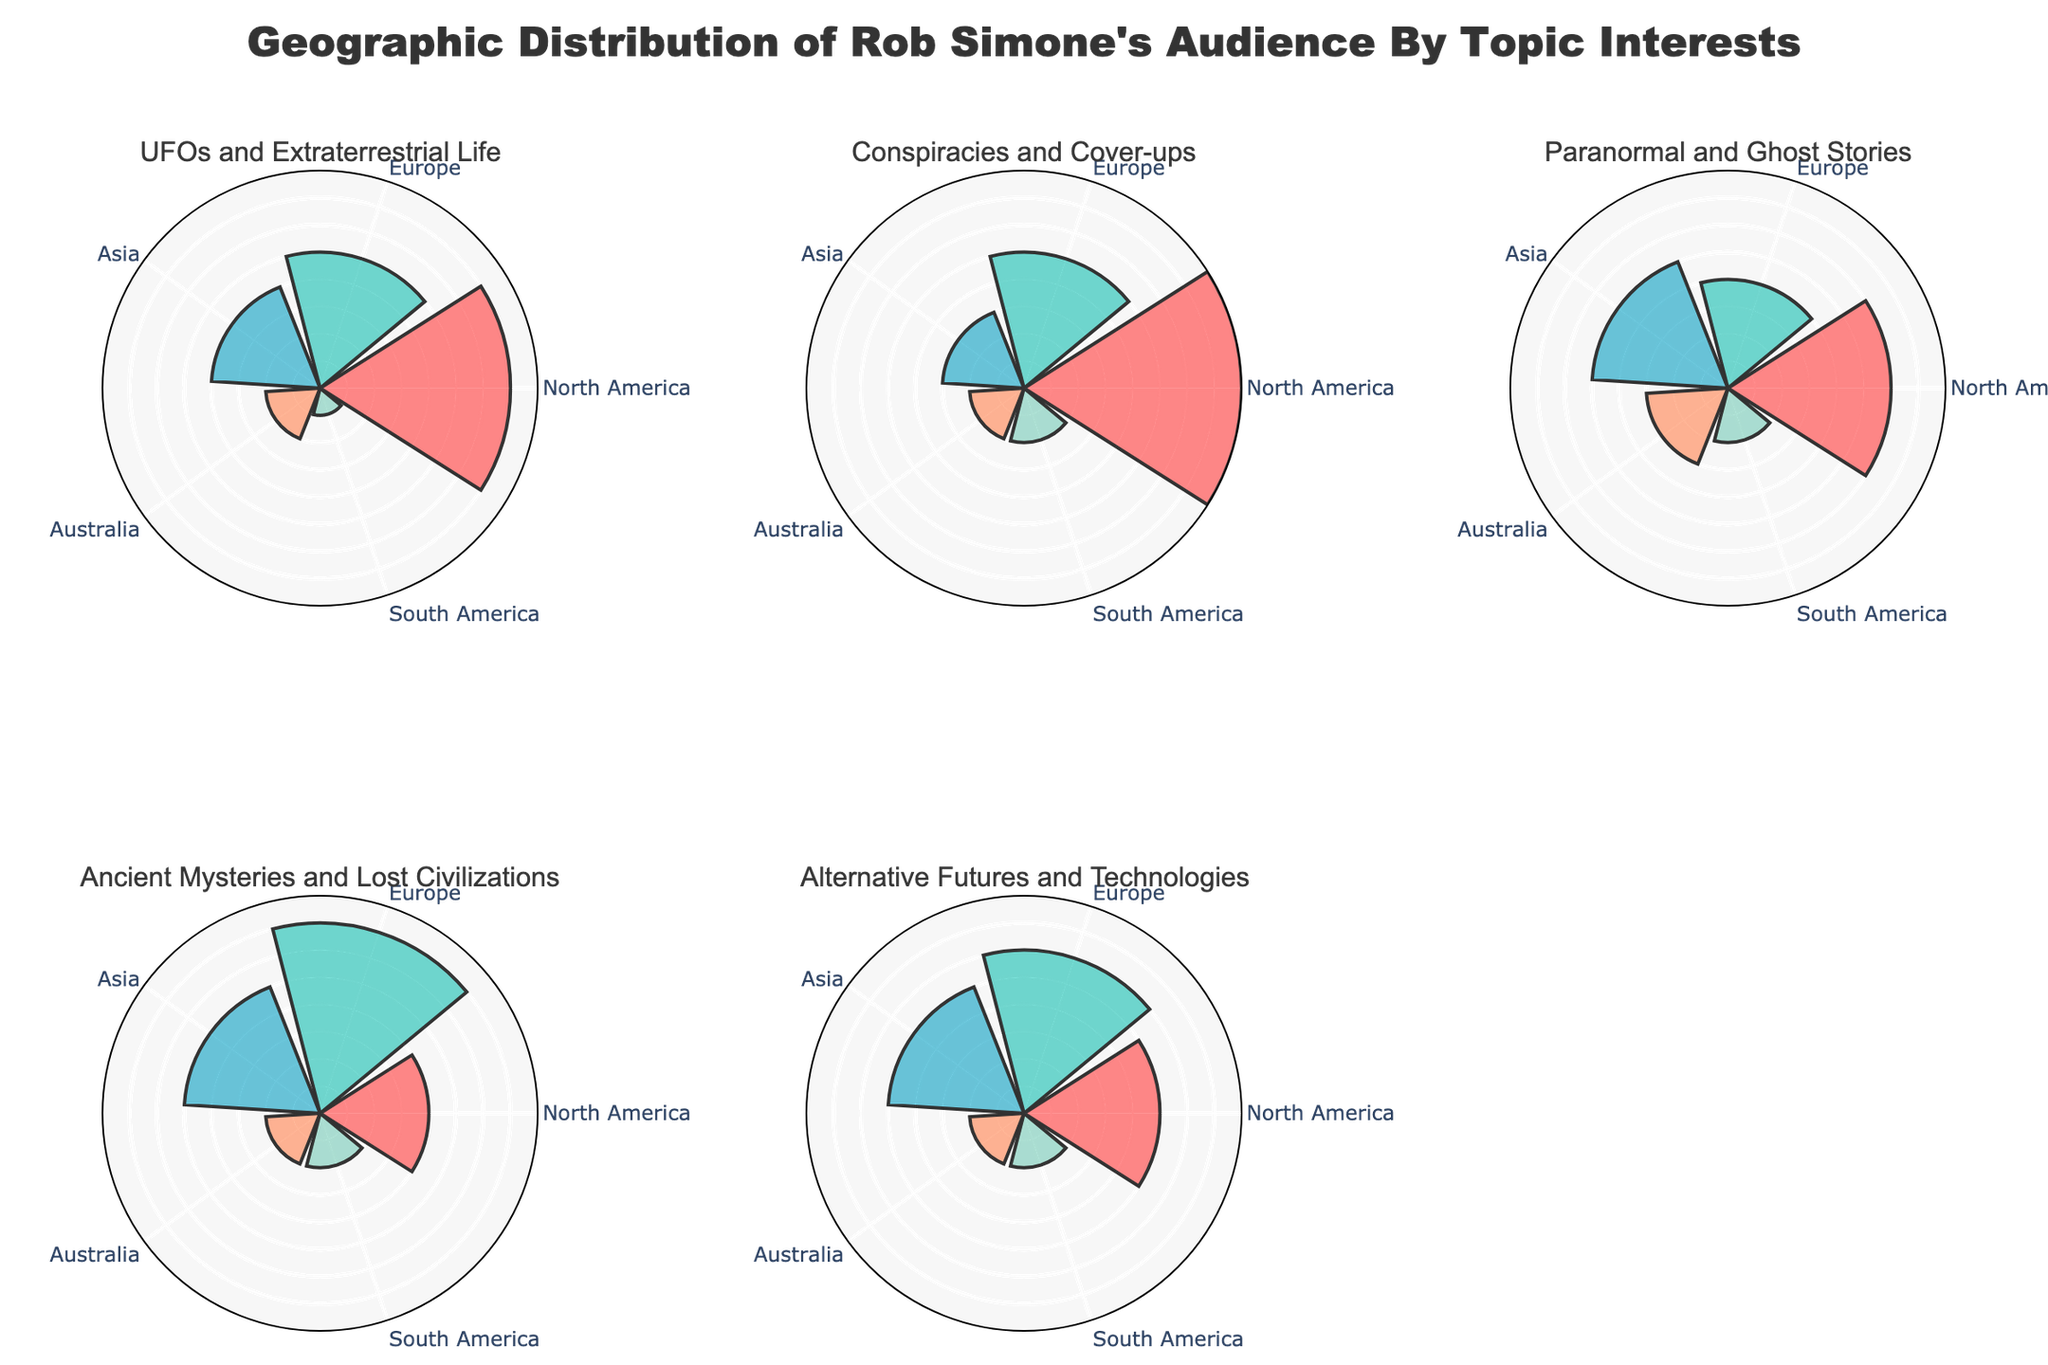What topic has the highest interest level in North America? The subplot for North America shows that "Conspiracies and Cover-ups" has the highest bar length indicating the interest level.
Answer: Conspiracies and Cover-ups Which region shows the lowest interest in "UFOs and Extraterrestrial Life"? By looking at the subplot for "UFOs and Extraterrestrial Life," the smallest bar is in the South America section.
Answer: South America What is the combined interest level in Asia for "Paranormal and Ghost Stories" and "Ancient Mysteries and Lost Civilizations"? For these topics, the interest levels in Asia are 25 and 25, respectively. Adding them together: 25 + 25 = 50.
Answer: 50 Which topic has evenly distributed interest levels across five regions? Observing all subplots, "UFOs and Extraterrestrial Life" shows the most even distribution with values: 35 (North America), 25 (Europe), 20 (Asia), 10 (Australia), 5 (South America).
Answer: UFOs and Extraterrestrial Life Is the interest level in Europe higher or lower for "Alternative Futures and Technologies" compared to "Ancient Mysteries and Lost Civilizations"? Comparing the respective subplots for Europe, "Alternative Futures and Technologies" has 30, while "Ancient Mysteries and Lost Civilizations" has 35.
Answer: Lower Which topic shows the greatest variation in interest level across regions? Looking at the range of bars, "Paranormal and Ghost Stories" spans from 10 to 30, a variation of 20, while others have a smaller range.
Answer: Paranormal and Ghost Stories What is the average interest level in Australia across all topics? Calculating the values: (10 + 10 + 15 + 10 + 10) / 5 = 11.
Answer: 11 For "Conspiracies and Cover-ups," which two regions have the same interest level? By observing the bars for the topic "Conspiracies and Cover-ups," Australia and South America both have an interest level of 10.
Answer: Australia and South America Across all topics, which region consistently shows the highest levels of interest? By analyzing the aggregate values in subplots, North America commonly has the highest or one of the highest levels of interest in every topic.
Answer: North America What's the total interest level for "Alternative Futures and Technologies" across all regions? Summing the values for this topic across regions: 25 (North America) + 30 (Europe) + 25 (Asia) + 10 (Australia) + 10 (South America) = 100.
Answer: 100 